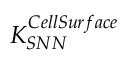Convert formula to latex. <formula><loc_0><loc_0><loc_500><loc_500>K _ { S N N } ^ { C e l l S u r f a c e }</formula> 